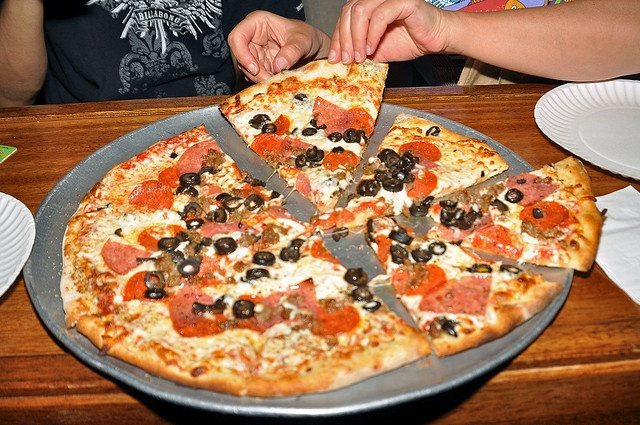Describe the objects in this image and their specific colors. I can see pizza in black, orange, red, tan, and beige tones, dining table in black, brown, and maroon tones, people in black and salmon tones, and people in black, gray, and brown tones in this image. 